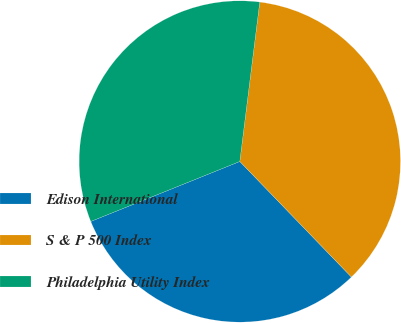<chart> <loc_0><loc_0><loc_500><loc_500><pie_chart><fcel>Edison International<fcel>S & P 500 Index<fcel>Philadelphia Utility Index<nl><fcel>31.13%<fcel>35.8%<fcel>33.07%<nl></chart> 